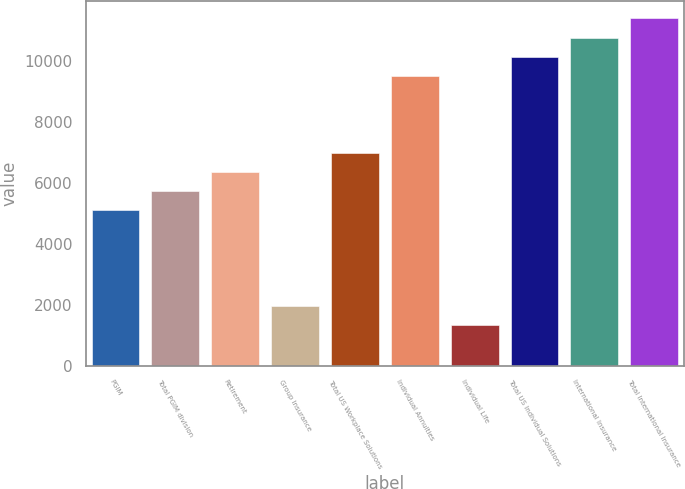Convert chart. <chart><loc_0><loc_0><loc_500><loc_500><bar_chart><fcel>PGIM<fcel>Total PGIM division<fcel>Retirement<fcel>Group Insurance<fcel>Total US Workplace Solutions<fcel>Individual Annuities<fcel>Individual Life<fcel>Total US Individual Solutions<fcel>International Insurance<fcel>Total International Insurance<nl><fcel>5106.8<fcel>5737.4<fcel>6368<fcel>1953.8<fcel>6998.6<fcel>9521<fcel>1323.2<fcel>10151.6<fcel>10782.2<fcel>11412.8<nl></chart> 